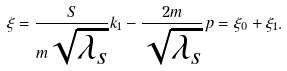<formula> <loc_0><loc_0><loc_500><loc_500>\xi = { \frac { S } { m \sqrt { \lambda _ { s } } } } k _ { 1 } - { \frac { 2 m } { \sqrt { \lambda _ { s } } } } p = \xi _ { 0 } + \xi _ { 1 } .</formula> 